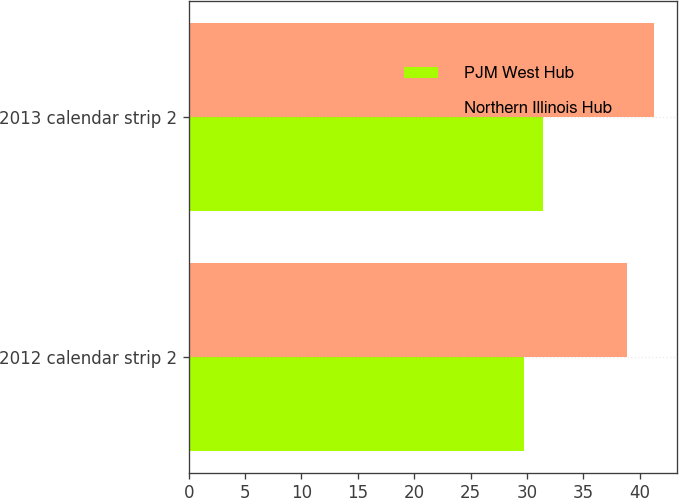<chart> <loc_0><loc_0><loc_500><loc_500><stacked_bar_chart><ecel><fcel>2012 calendar strip 2<fcel>2013 calendar strip 2<nl><fcel>PJM West Hub<fcel>29.75<fcel>31.41<nl><fcel>Northern Illinois Hub<fcel>38.85<fcel>41.26<nl></chart> 